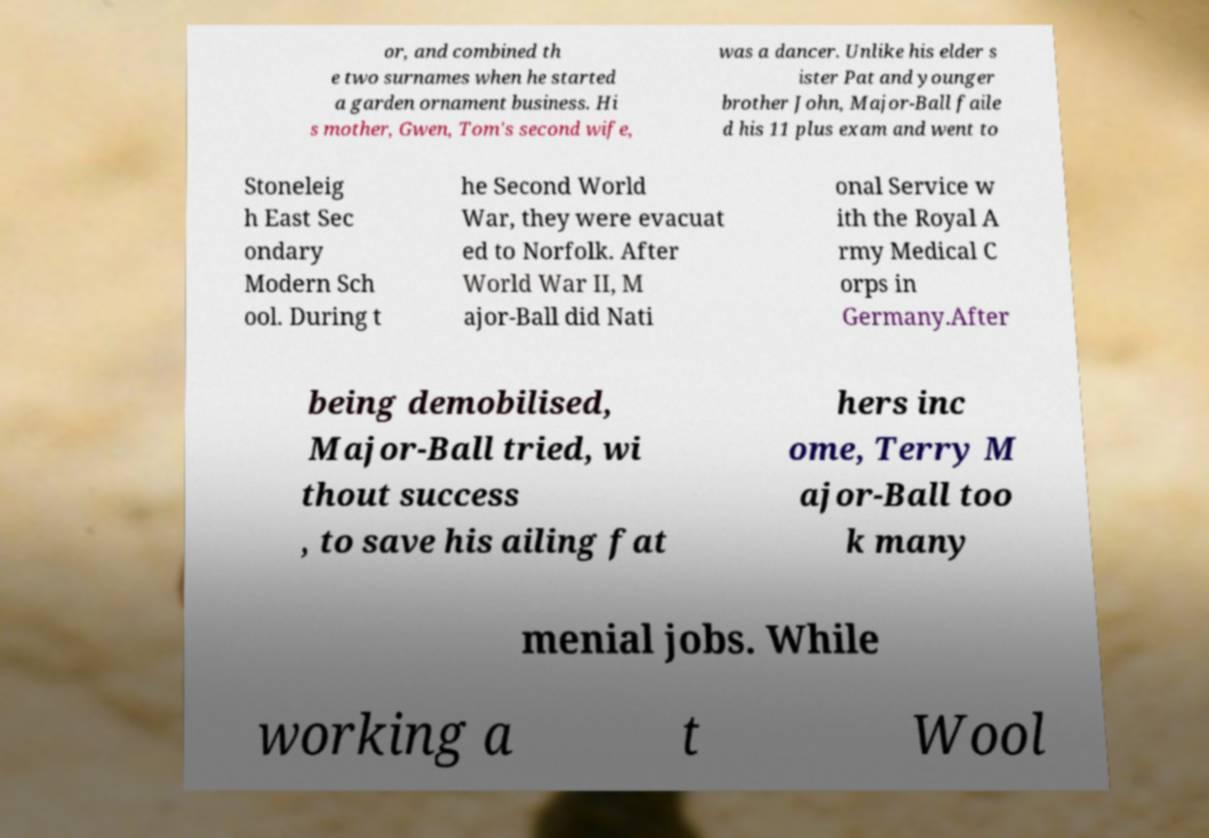What messages or text are displayed in this image? I need them in a readable, typed format. or, and combined th e two surnames when he started a garden ornament business. Hi s mother, Gwen, Tom's second wife, was a dancer. Unlike his elder s ister Pat and younger brother John, Major-Ball faile d his 11 plus exam and went to Stoneleig h East Sec ondary Modern Sch ool. During t he Second World War, they were evacuat ed to Norfolk. After World War II, M ajor-Ball did Nati onal Service w ith the Royal A rmy Medical C orps in Germany.After being demobilised, Major-Ball tried, wi thout success , to save his ailing fat hers inc ome, Terry M ajor-Ball too k many menial jobs. While working a t Wool 